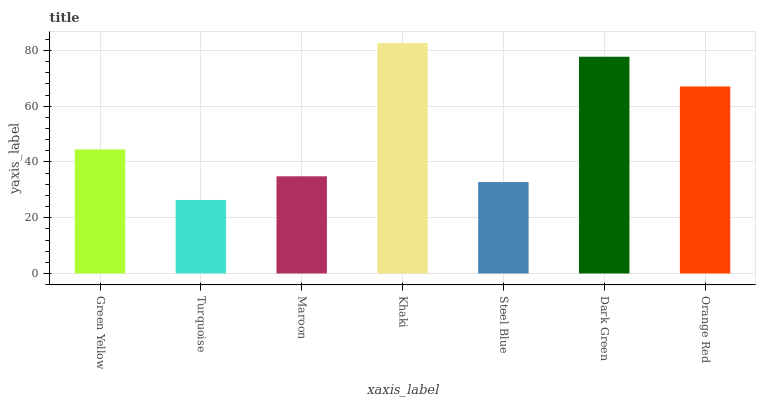Is Turquoise the minimum?
Answer yes or no. Yes. Is Khaki the maximum?
Answer yes or no. Yes. Is Maroon the minimum?
Answer yes or no. No. Is Maroon the maximum?
Answer yes or no. No. Is Maroon greater than Turquoise?
Answer yes or no. Yes. Is Turquoise less than Maroon?
Answer yes or no. Yes. Is Turquoise greater than Maroon?
Answer yes or no. No. Is Maroon less than Turquoise?
Answer yes or no. No. Is Green Yellow the high median?
Answer yes or no. Yes. Is Green Yellow the low median?
Answer yes or no. Yes. Is Khaki the high median?
Answer yes or no. No. Is Orange Red the low median?
Answer yes or no. No. 